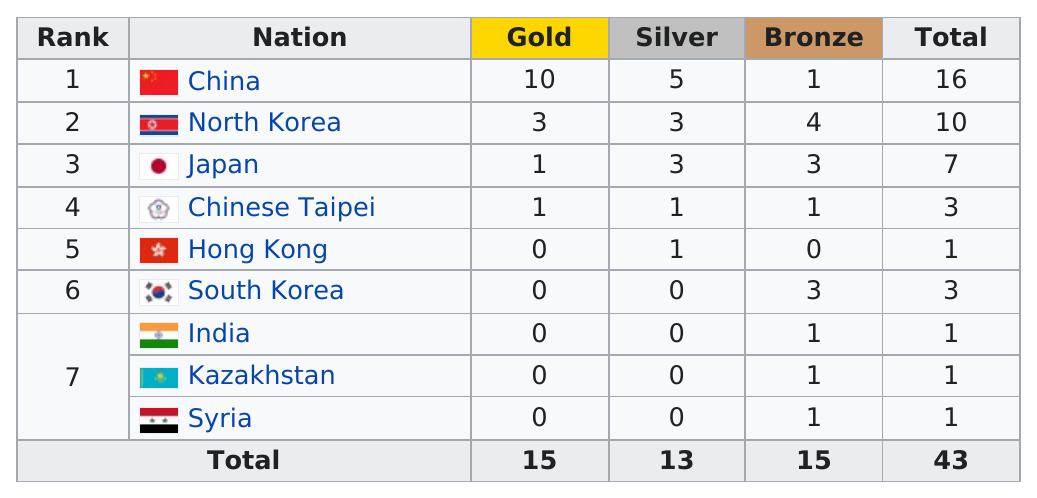Highlight a few significant elements in this photo. The number of nations that won more than two gold medals is 2. Hong Kong has won more silver medals than Syria. North Korea received a total of 10 medals in the games. The fact is that China is the only country to have won more than four silver medals. China or North Korea obtained 5 silver medals. 